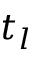<formula> <loc_0><loc_0><loc_500><loc_500>t _ { l }</formula> 